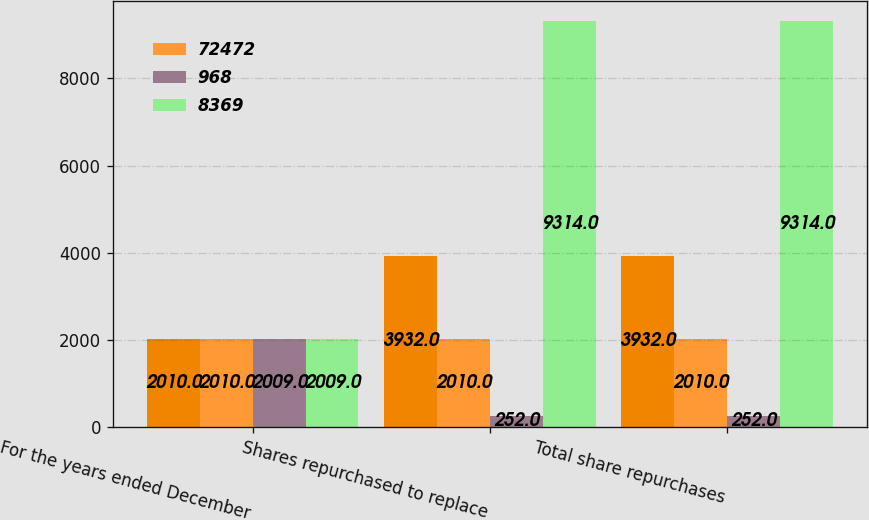<chart> <loc_0><loc_0><loc_500><loc_500><stacked_bar_chart><ecel><fcel>For the years ended December<fcel>Shares repurchased to replace<fcel>Total share repurchases<nl><fcel>nan<fcel>2010<fcel>3932<fcel>3932<nl><fcel>72472<fcel>2010<fcel>2010<fcel>2010<nl><fcel>968<fcel>2009<fcel>252<fcel>252<nl><fcel>8369<fcel>2009<fcel>9314<fcel>9314<nl></chart> 